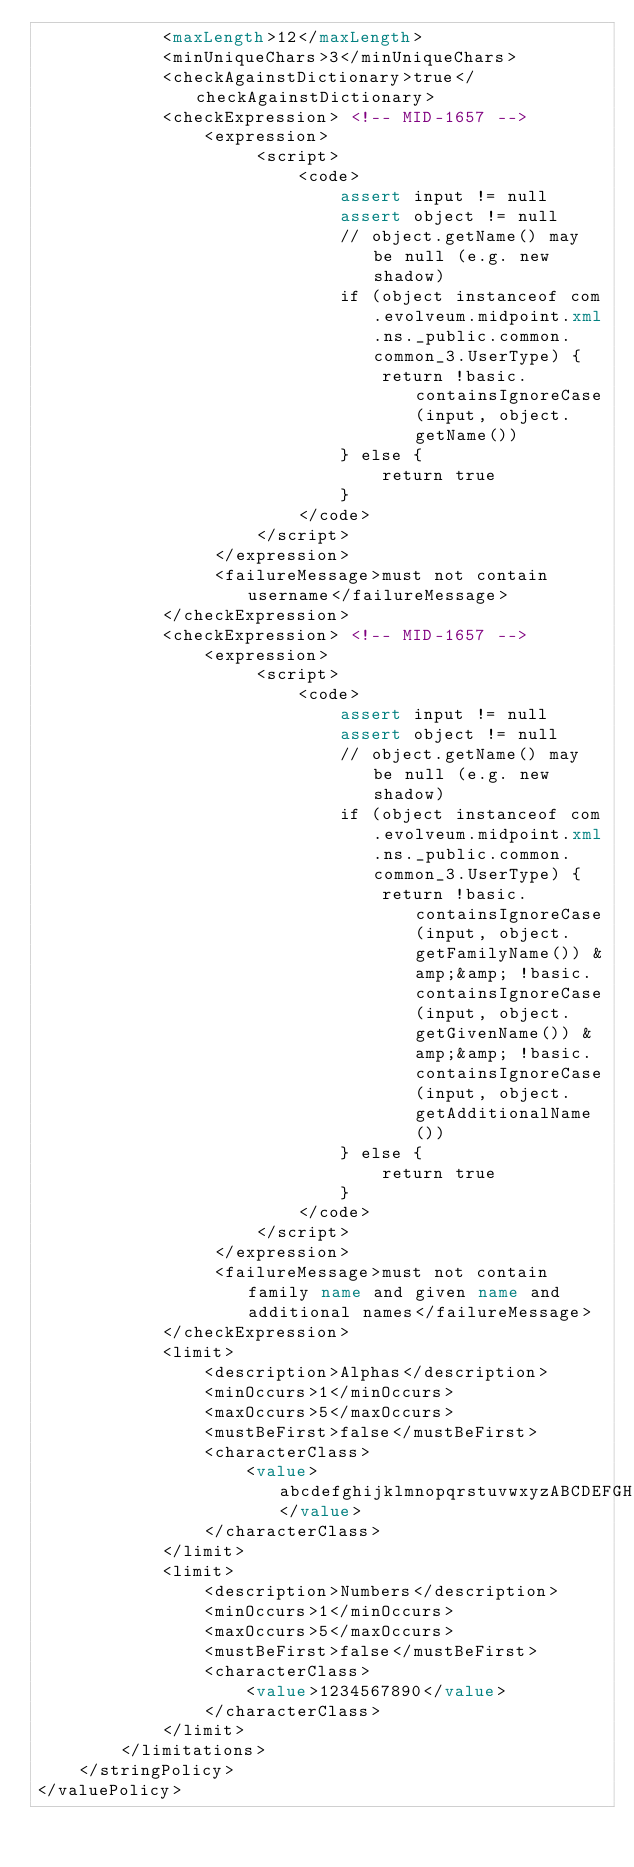Convert code to text. <code><loc_0><loc_0><loc_500><loc_500><_XML_>            <maxLength>12</maxLength>
            <minUniqueChars>3</minUniqueChars>
            <checkAgainstDictionary>true</checkAgainstDictionary>
            <checkExpression> <!-- MID-1657 -->
                <expression>
                     <script>
                         <code>
                             assert input != null
                             assert object != null
                             // object.getName() may be null (e.g. new shadow)
                             if (object instanceof com.evolveum.midpoint.xml.ns._public.common.common_3.UserType) {
                                 return !basic.containsIgnoreCase(input, object.getName())
                             } else {
                                 return true
                             }
                         </code>
                     </script>
                 </expression>
                 <failureMessage>must not contain username</failureMessage>
            </checkExpression>
            <checkExpression> <!-- MID-1657 -->
                <expression>
                     <script>
                         <code>
                             assert input != null
                             assert object != null
                             // object.getName() may be null (e.g. new shadow)
                             if (object instanceof com.evolveum.midpoint.xml.ns._public.common.common_3.UserType) {
                                 return !basic.containsIgnoreCase(input, object.getFamilyName()) &amp;&amp; !basic.containsIgnoreCase(input, object.getGivenName()) &amp;&amp; !basic.containsIgnoreCase(input, object.getAdditionalName())
                             } else {
                                 return true
                             }
                         </code>
                     </script>
                 </expression>
                 <failureMessage>must not contain family name and given name and additional names</failureMessage>
            </checkExpression>
            <limit>
                <description>Alphas</description>
                <minOccurs>1</minOccurs>
                <maxOccurs>5</maxOccurs>
                <mustBeFirst>false</mustBeFirst>
                <characterClass>
                    <value>abcdefghijklmnopqrstuvwxyzABCDEFGHIJKLMNOPQRSTUVWXYZ</value>
                </characterClass>
            </limit>
            <limit>
                <description>Numbers</description>
                <minOccurs>1</minOccurs>
                <maxOccurs>5</maxOccurs>
                <mustBeFirst>false</mustBeFirst>
                <characterClass>
                    <value>1234567890</value>
                </characterClass>
            </limit>
        </limitations>
    </stringPolicy>
</valuePolicy>
</code> 